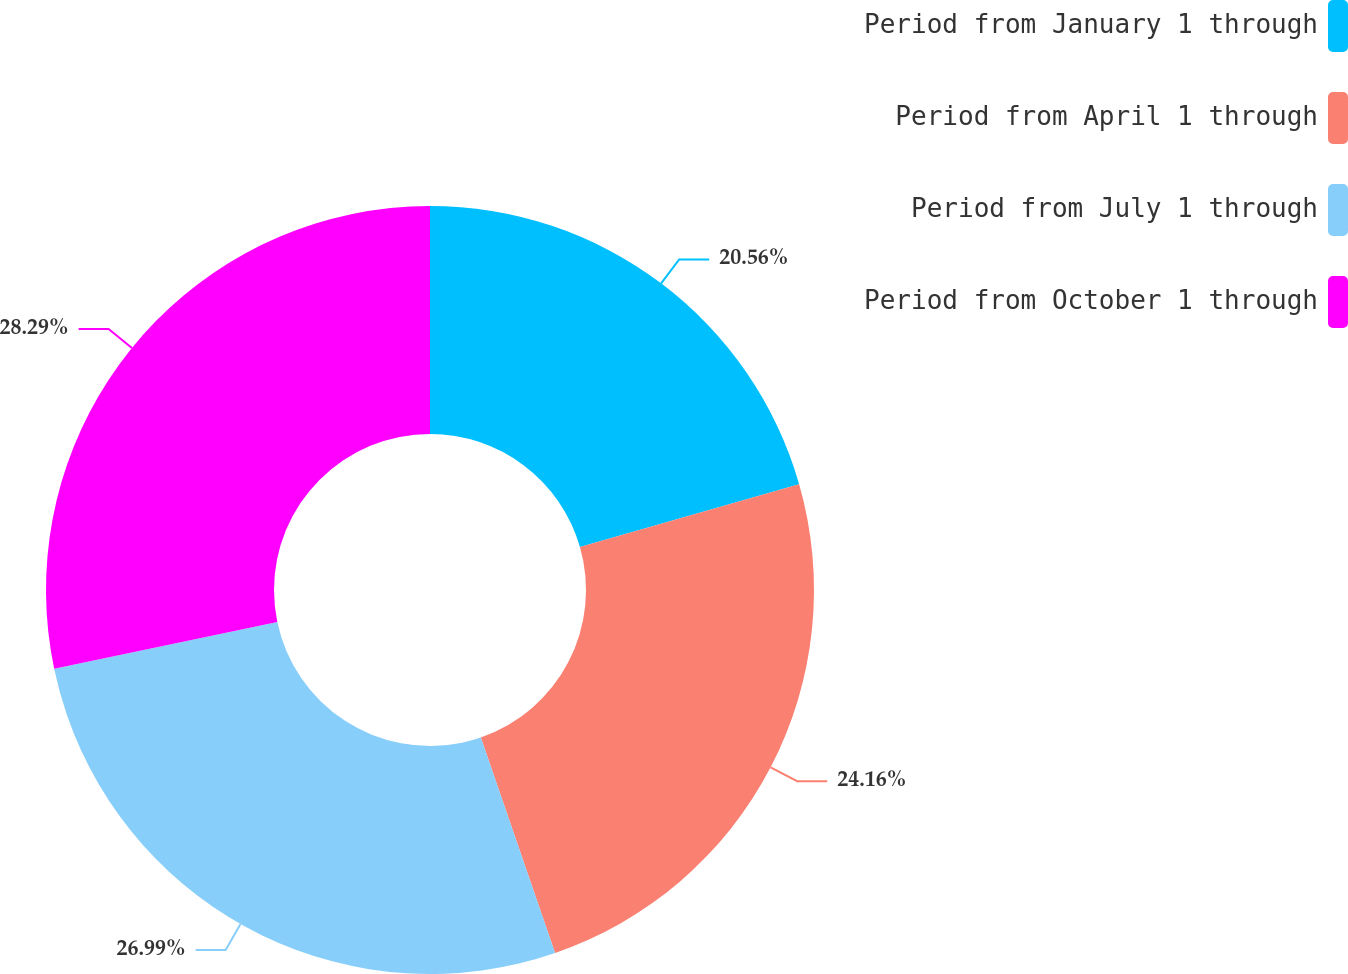<chart> <loc_0><loc_0><loc_500><loc_500><pie_chart><fcel>Period from January 1 through<fcel>Period from April 1 through<fcel>Period from July 1 through<fcel>Period from October 1 through<nl><fcel>20.56%<fcel>24.16%<fcel>26.99%<fcel>28.29%<nl></chart> 